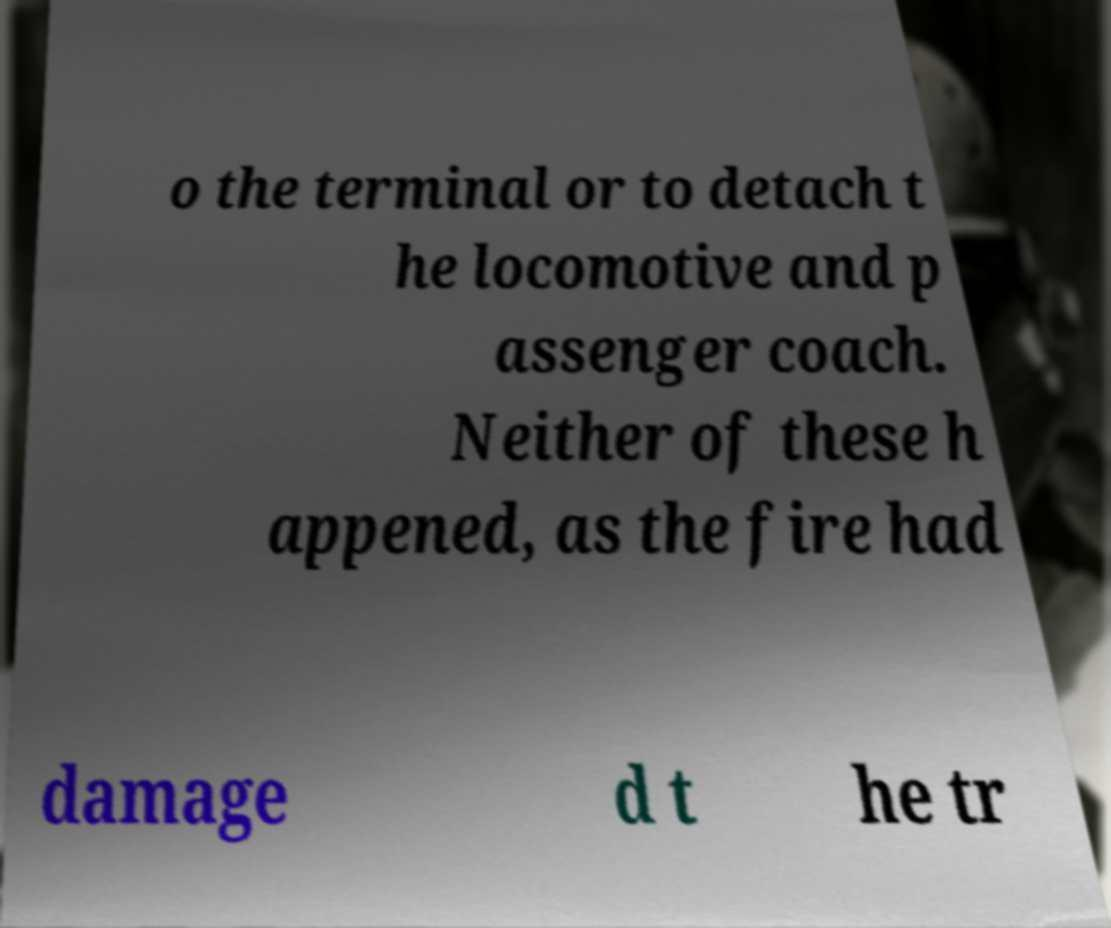Can you accurately transcribe the text from the provided image for me? o the terminal or to detach t he locomotive and p assenger coach. Neither of these h appened, as the fire had damage d t he tr 